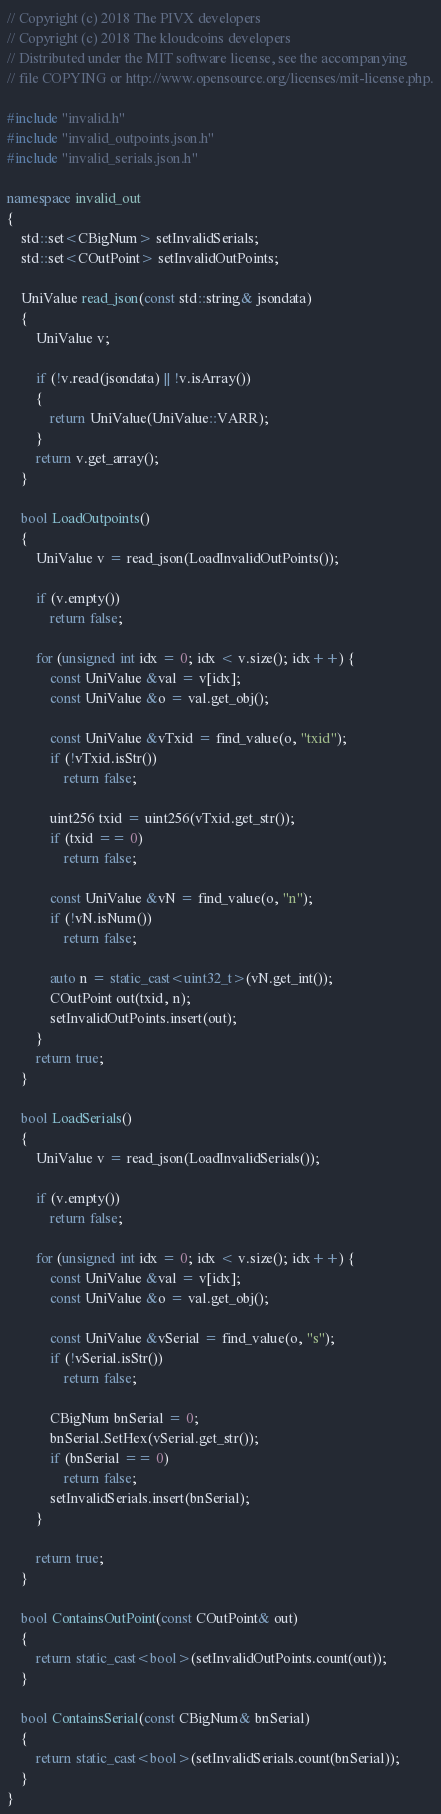Convert code to text. <code><loc_0><loc_0><loc_500><loc_500><_C++_>// Copyright (c) 2018 The PIVX developers
// Copyright (c) 2018 The kloudcoins developers
// Distributed under the MIT software license, see the accompanying
// file COPYING or http://www.opensource.org/licenses/mit-license.php.

#include "invalid.h"
#include "invalid_outpoints.json.h"
#include "invalid_serials.json.h"

namespace invalid_out
{
    std::set<CBigNum> setInvalidSerials;
    std::set<COutPoint> setInvalidOutPoints;

    UniValue read_json(const std::string& jsondata)
    {
        UniValue v;

        if (!v.read(jsondata) || !v.isArray())
        {
            return UniValue(UniValue::VARR);
        }
        return v.get_array();
    }

    bool LoadOutpoints()
    {
        UniValue v = read_json(LoadInvalidOutPoints());

        if (v.empty())
            return false;

        for (unsigned int idx = 0; idx < v.size(); idx++) {
            const UniValue &val = v[idx];
            const UniValue &o = val.get_obj();

            const UniValue &vTxid = find_value(o, "txid");
            if (!vTxid.isStr())
                return false;

            uint256 txid = uint256(vTxid.get_str());
            if (txid == 0)
                return false;

            const UniValue &vN = find_value(o, "n");
            if (!vN.isNum())
                return false;

            auto n = static_cast<uint32_t>(vN.get_int());
            COutPoint out(txid, n);
            setInvalidOutPoints.insert(out);
        }
        return true;
    }

    bool LoadSerials()
    {
        UniValue v = read_json(LoadInvalidSerials());

        if (v.empty())
            return false;

        for (unsigned int idx = 0; idx < v.size(); idx++) {
            const UniValue &val = v[idx];
            const UniValue &o = val.get_obj();

            const UniValue &vSerial = find_value(o, "s");
            if (!vSerial.isStr())
                return false;

            CBigNum bnSerial = 0;
            bnSerial.SetHex(vSerial.get_str());
            if (bnSerial == 0)
                return false;
            setInvalidSerials.insert(bnSerial);
        }

        return true;
    }

    bool ContainsOutPoint(const COutPoint& out)
    {
        return static_cast<bool>(setInvalidOutPoints.count(out));
    }

    bool ContainsSerial(const CBigNum& bnSerial)
    {
        return static_cast<bool>(setInvalidSerials.count(bnSerial));
    }
}

</code> 